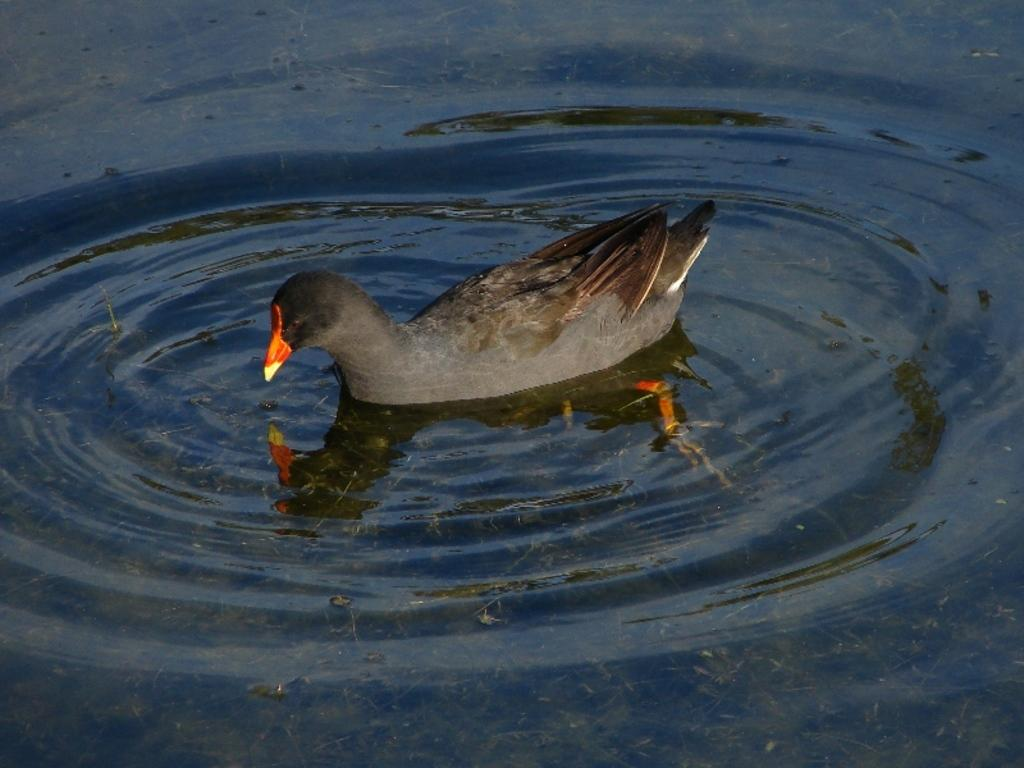What is the primary element visible in the image? There is water in the image. Can you describe any living creatures present in the image? There is a grey-colored bird in the water. How many cherries are floating on the water in the image? There are no cherries present in the image; it only features water and a grey-colored bird. 